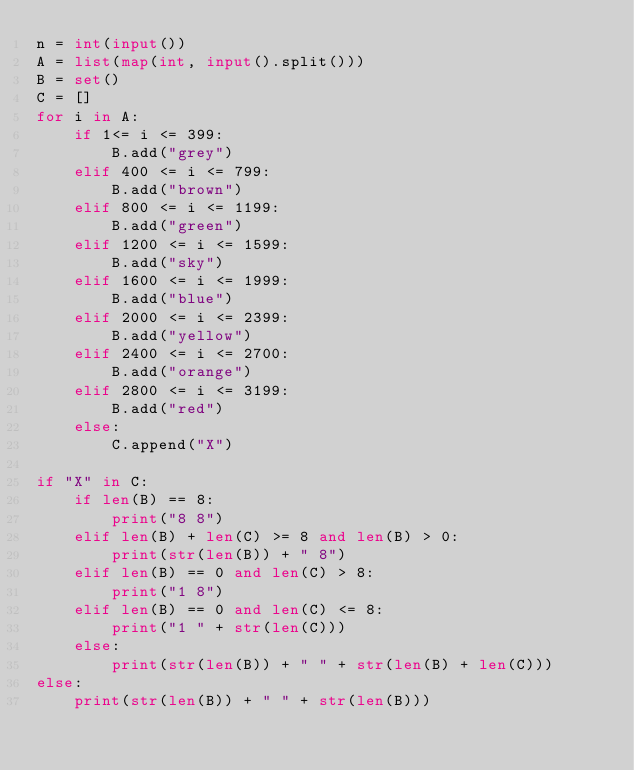Convert code to text. <code><loc_0><loc_0><loc_500><loc_500><_Python_>n = int(input())
A = list(map(int, input().split()))
B = set()
C = []
for i in A:
    if 1<= i <= 399:
        B.add("grey")
    elif 400 <= i <= 799:
        B.add("brown")
    elif 800 <= i <= 1199:
        B.add("green")
    elif 1200 <= i <= 1599:
        B.add("sky")
    elif 1600 <= i <= 1999:
        B.add("blue")
    elif 2000 <= i <= 2399:
        B.add("yellow")
    elif 2400 <= i <= 2700:
        B.add("orange")
    elif 2800 <= i <= 3199:
        B.add("red")
    else:
        C.append("X")

if "X" in C:
    if len(B) == 8:
        print("8 8")
    elif len(B) + len(C) >= 8 and len(B) > 0:
        print(str(len(B)) + " 8")
    elif len(B) == 0 and len(C) > 8:
        print("1 8")
    elif len(B) == 0 and len(C) <= 8:
        print("1 " + str(len(C)))
    else:
        print(str(len(B)) + " " + str(len(B) + len(C)))
else:
    print(str(len(B)) + " " + str(len(B)))</code> 